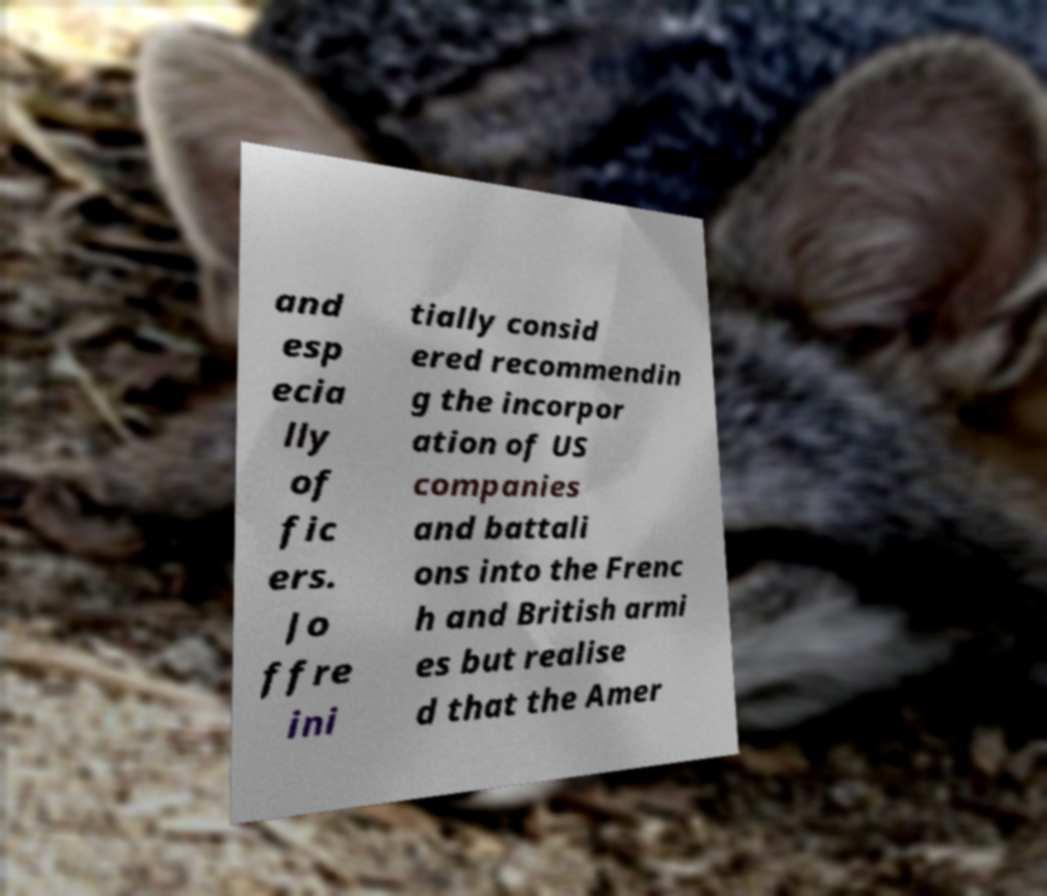Please read and relay the text visible in this image. What does it say? and esp ecia lly of fic ers. Jo ffre ini tially consid ered recommendin g the incorpor ation of US companies and battali ons into the Frenc h and British armi es but realise d that the Amer 